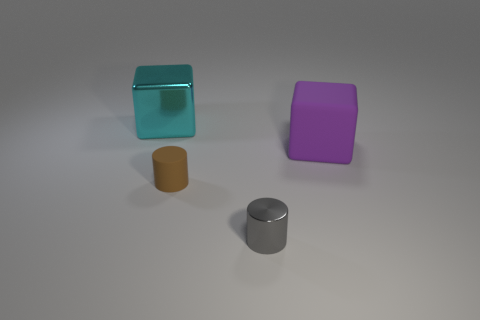Add 3 big red balls. How many objects exist? 7 Subtract 0 green spheres. How many objects are left? 4 Subtract all big blue metal cubes. Subtract all brown matte things. How many objects are left? 3 Add 2 purple blocks. How many purple blocks are left? 3 Add 4 big cyan objects. How many big cyan objects exist? 5 